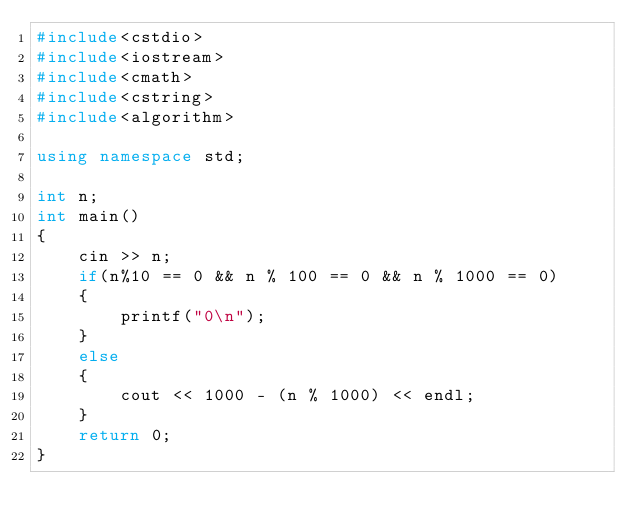<code> <loc_0><loc_0><loc_500><loc_500><_C++_>#include<cstdio>
#include<iostream>
#include<cmath>
#include<cstring>
#include<algorithm>

using namespace std;

int n;
int main()
{
	cin >> n;
	if(n%10 == 0 && n % 100 == 0 && n % 1000 == 0)
	{
		printf("0\n");
	}
	else
	{
		cout << 1000 - (n % 1000) << endl;
	}
	return 0;
}</code> 